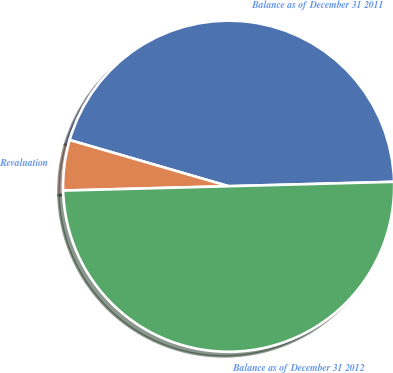Convert chart to OTSL. <chart><loc_0><loc_0><loc_500><loc_500><pie_chart><fcel>Balance as of December 31 2011<fcel>Revaluation<fcel>Balance as of December 31 2012<nl><fcel>45.08%<fcel>4.92%<fcel>50.0%<nl></chart> 